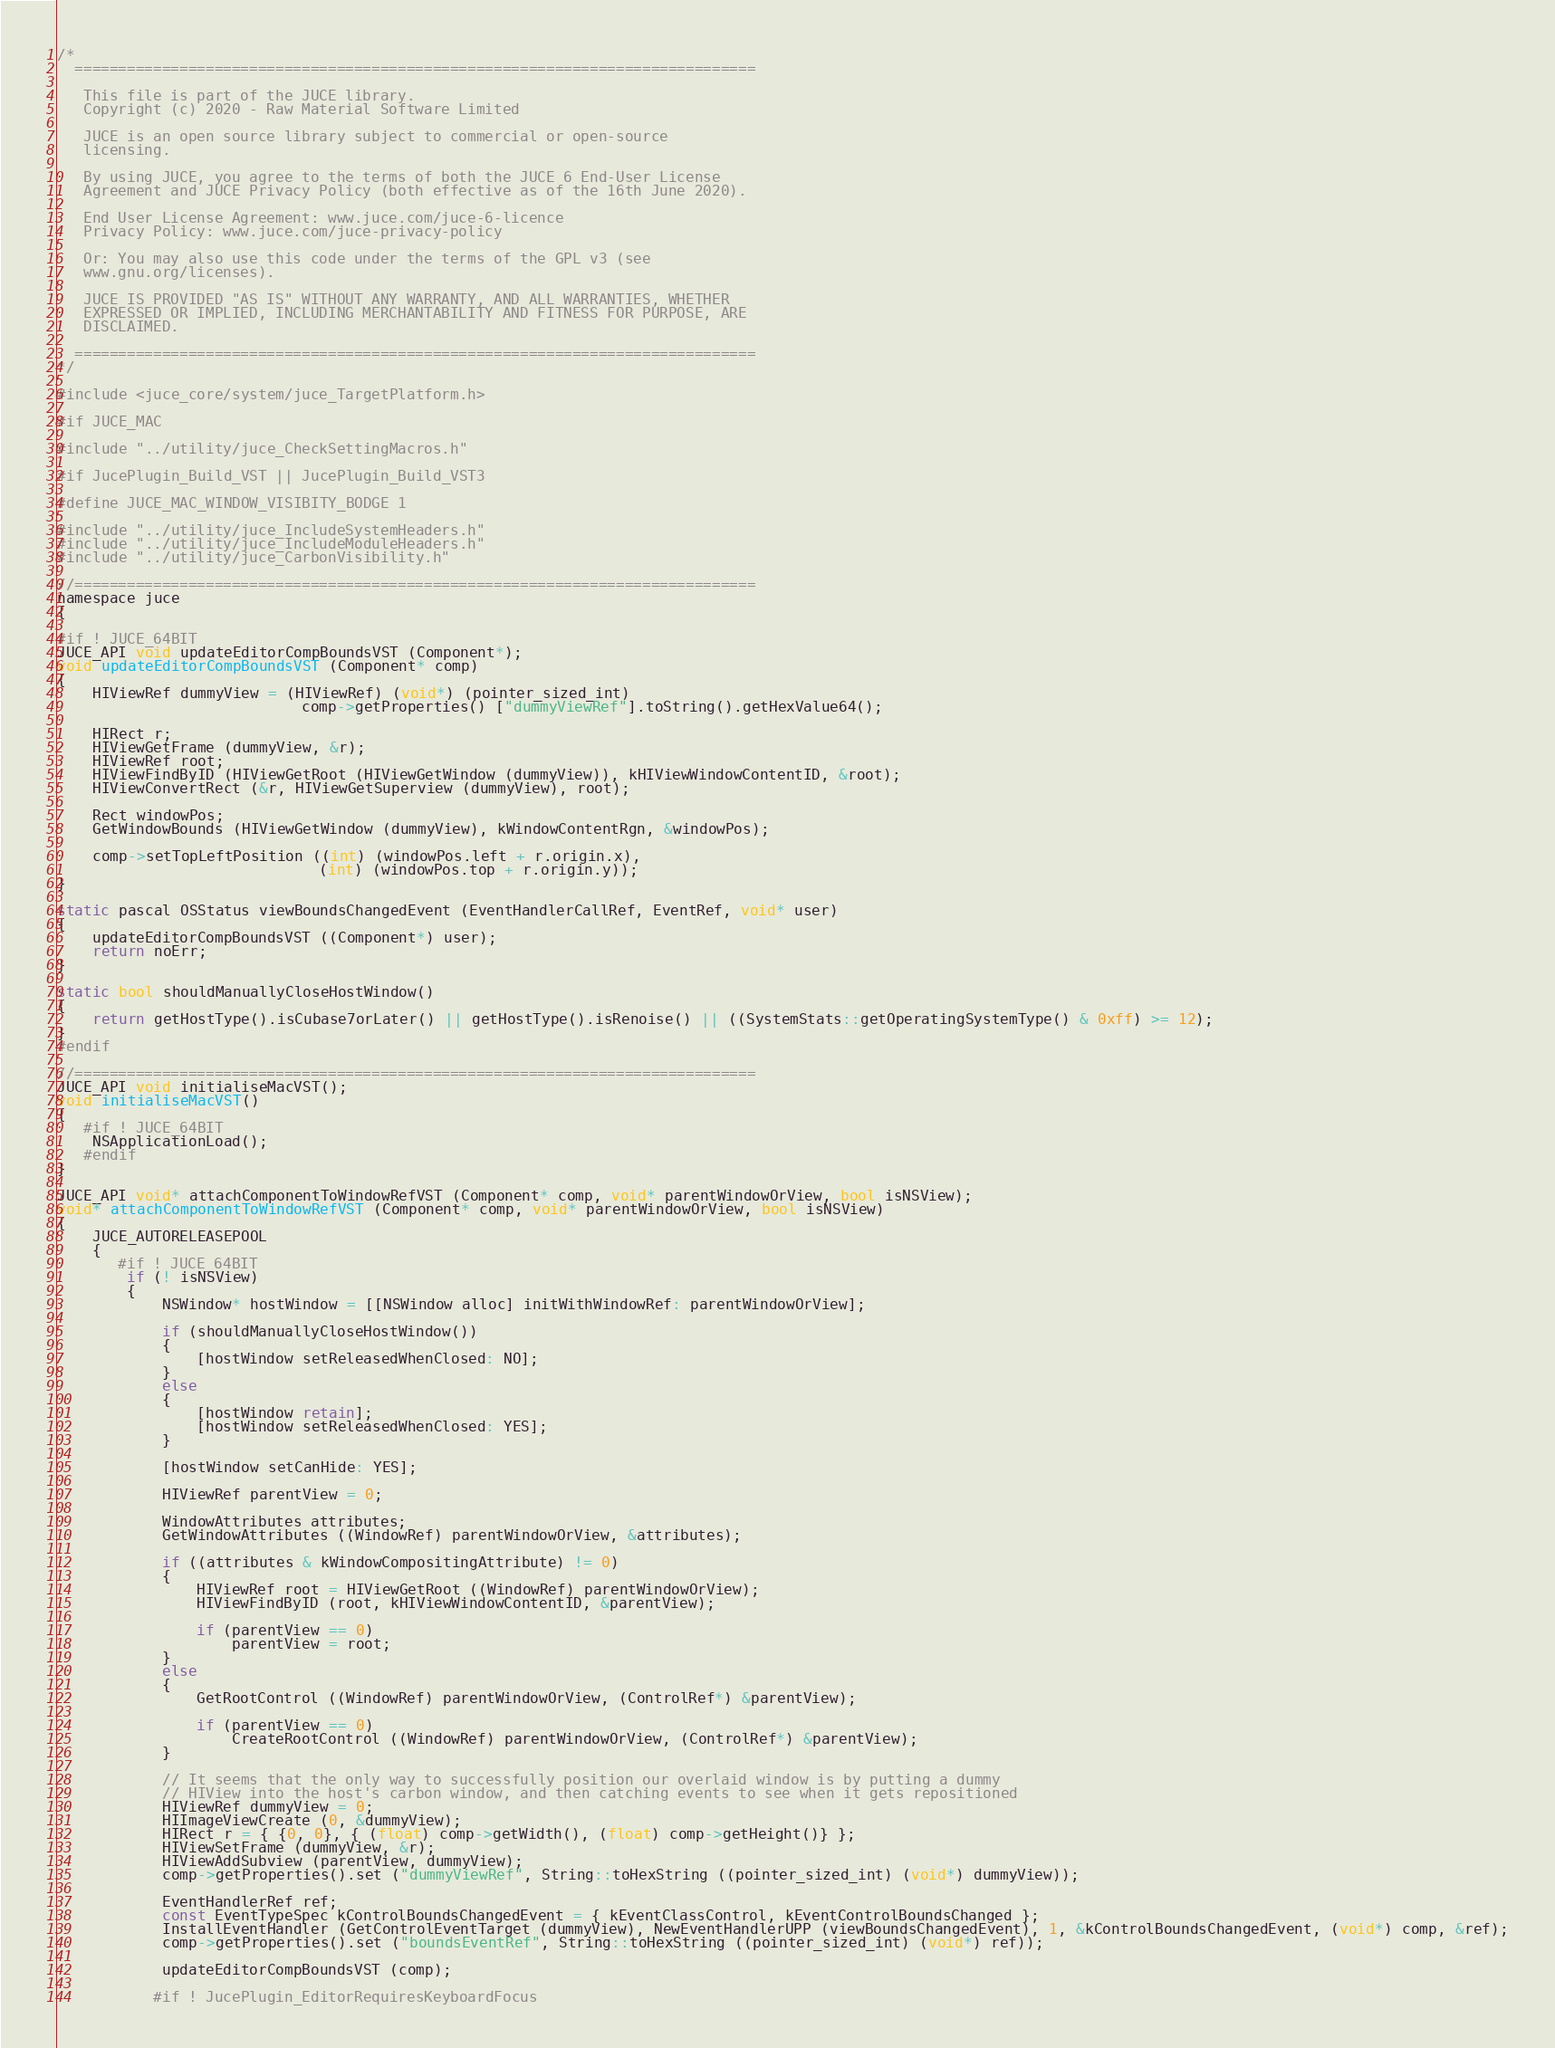<code> <loc_0><loc_0><loc_500><loc_500><_ObjectiveC_>/*
  ==============================================================================

   This file is part of the JUCE library.
   Copyright (c) 2020 - Raw Material Software Limited

   JUCE is an open source library subject to commercial or open-source
   licensing.

   By using JUCE, you agree to the terms of both the JUCE 6 End-User License
   Agreement and JUCE Privacy Policy (both effective as of the 16th June 2020).

   End User License Agreement: www.juce.com/juce-6-licence
   Privacy Policy: www.juce.com/juce-privacy-policy

   Or: You may also use this code under the terms of the GPL v3 (see
   www.gnu.org/licenses).

   JUCE IS PROVIDED "AS IS" WITHOUT ANY WARRANTY, AND ALL WARRANTIES, WHETHER
   EXPRESSED OR IMPLIED, INCLUDING MERCHANTABILITY AND FITNESS FOR PURPOSE, ARE
   DISCLAIMED.

  ==============================================================================
*/

#include <juce_core/system/juce_TargetPlatform.h>

#if JUCE_MAC

#include "../utility/juce_CheckSettingMacros.h"

#if JucePlugin_Build_VST || JucePlugin_Build_VST3

#define JUCE_MAC_WINDOW_VISIBITY_BODGE 1

#include "../utility/juce_IncludeSystemHeaders.h"
#include "../utility/juce_IncludeModuleHeaders.h"
#include "../utility/juce_CarbonVisibility.h"

//==============================================================================
namespace juce
{

#if ! JUCE_64BIT
JUCE_API void updateEditorCompBoundsVST (Component*);
void updateEditorCompBoundsVST (Component* comp)
{
    HIViewRef dummyView = (HIViewRef) (void*) (pointer_sized_int)
                            comp->getProperties() ["dummyViewRef"].toString().getHexValue64();

    HIRect r;
    HIViewGetFrame (dummyView, &r);
    HIViewRef root;
    HIViewFindByID (HIViewGetRoot (HIViewGetWindow (dummyView)), kHIViewWindowContentID, &root);
    HIViewConvertRect (&r, HIViewGetSuperview (dummyView), root);

    Rect windowPos;
    GetWindowBounds (HIViewGetWindow (dummyView), kWindowContentRgn, &windowPos);

    comp->setTopLeftPosition ((int) (windowPos.left + r.origin.x),
                              (int) (windowPos.top + r.origin.y));
}

static pascal OSStatus viewBoundsChangedEvent (EventHandlerCallRef, EventRef, void* user)
{
    updateEditorCompBoundsVST ((Component*) user);
    return noErr;
}

static bool shouldManuallyCloseHostWindow()
{
    return getHostType().isCubase7orLater() || getHostType().isRenoise() || ((SystemStats::getOperatingSystemType() & 0xff) >= 12);
}
#endif

//==============================================================================
JUCE_API void initialiseMacVST();
void initialiseMacVST()
{
   #if ! JUCE_64BIT
    NSApplicationLoad();
   #endif
}

JUCE_API void* attachComponentToWindowRefVST (Component* comp, void* parentWindowOrView, bool isNSView);
void* attachComponentToWindowRefVST (Component* comp, void* parentWindowOrView, bool isNSView)
{
    JUCE_AUTORELEASEPOOL
    {
       #if ! JUCE_64BIT
        if (! isNSView)
        {
            NSWindow* hostWindow = [[NSWindow alloc] initWithWindowRef: parentWindowOrView];

            if (shouldManuallyCloseHostWindow())
            {
                [hostWindow setReleasedWhenClosed: NO];
            }
            else
            {
                [hostWindow retain];
                [hostWindow setReleasedWhenClosed: YES];
            }

            [hostWindow setCanHide: YES];

            HIViewRef parentView = 0;

            WindowAttributes attributes;
            GetWindowAttributes ((WindowRef) parentWindowOrView, &attributes);

            if ((attributes & kWindowCompositingAttribute) != 0)
            {
                HIViewRef root = HIViewGetRoot ((WindowRef) parentWindowOrView);
                HIViewFindByID (root, kHIViewWindowContentID, &parentView);

                if (parentView == 0)
                    parentView = root;
            }
            else
            {
                GetRootControl ((WindowRef) parentWindowOrView, (ControlRef*) &parentView);

                if (parentView == 0)
                    CreateRootControl ((WindowRef) parentWindowOrView, (ControlRef*) &parentView);
            }

            // It seems that the only way to successfully position our overlaid window is by putting a dummy
            // HIView into the host's carbon window, and then catching events to see when it gets repositioned
            HIViewRef dummyView = 0;
            HIImageViewCreate (0, &dummyView);
            HIRect r = { {0, 0}, { (float) comp->getWidth(), (float) comp->getHeight()} };
            HIViewSetFrame (dummyView, &r);
            HIViewAddSubview (parentView, dummyView);
            comp->getProperties().set ("dummyViewRef", String::toHexString ((pointer_sized_int) (void*) dummyView));

            EventHandlerRef ref;
            const EventTypeSpec kControlBoundsChangedEvent = { kEventClassControl, kEventControlBoundsChanged };
            InstallEventHandler (GetControlEventTarget (dummyView), NewEventHandlerUPP (viewBoundsChangedEvent), 1, &kControlBoundsChangedEvent, (void*) comp, &ref);
            comp->getProperties().set ("boundsEventRef", String::toHexString ((pointer_sized_int) (void*) ref));

            updateEditorCompBoundsVST (comp);

           #if ! JucePlugin_EditorRequiresKeyboardFocus</code> 